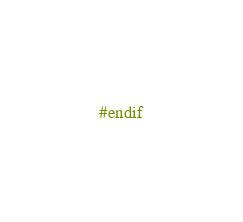Convert code to text. <code><loc_0><loc_0><loc_500><loc_500><_C_>#endif

</code> 